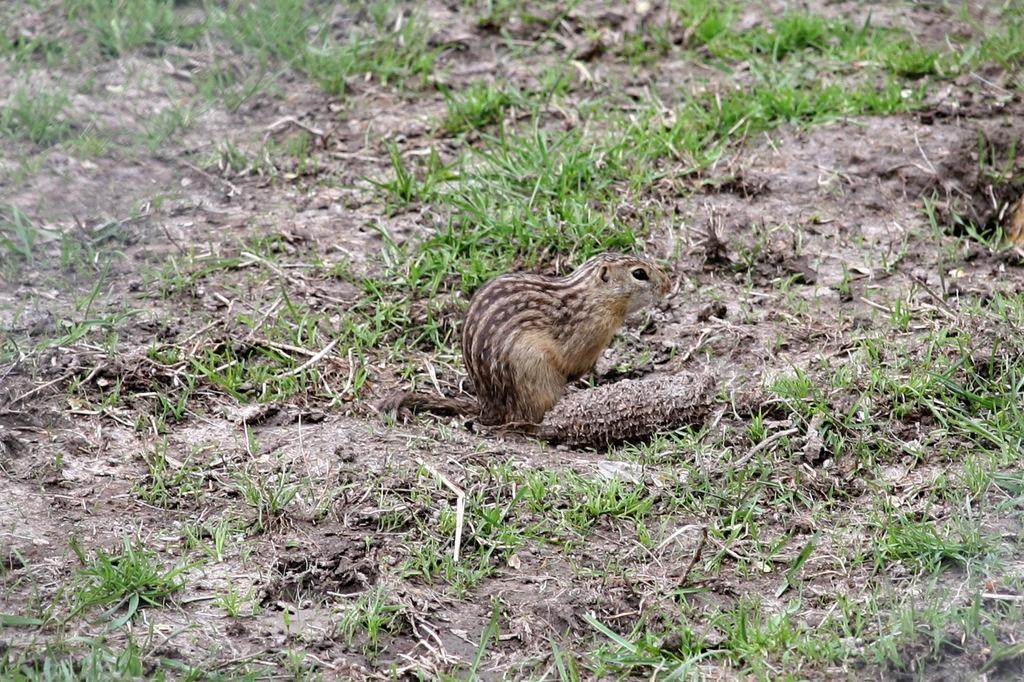What animal can be seen in the image? There is a squirrel in the image. Where is the squirrel located? The squirrel is standing on the grassland. What suggestion does the hen make to the squirrel in the image? There is no hen present in the image, so it is not possible to answer that question. 